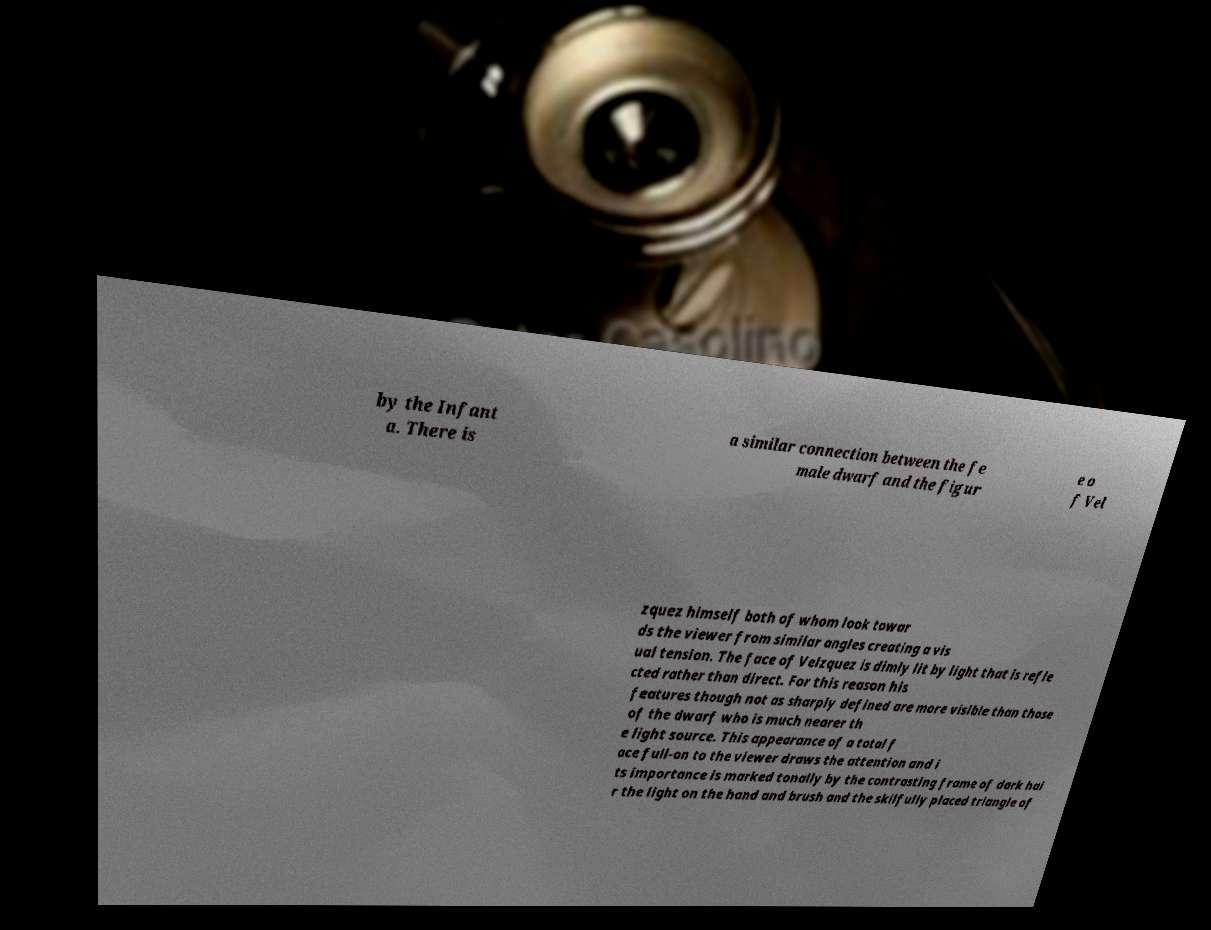What messages or text are displayed in this image? I need them in a readable, typed format. by the Infant a. There is a similar connection between the fe male dwarf and the figur e o f Vel zquez himself both of whom look towar ds the viewer from similar angles creating a vis ual tension. The face of Velzquez is dimly lit by light that is refle cted rather than direct. For this reason his features though not as sharply defined are more visible than those of the dwarf who is much nearer th e light source. This appearance of a total f ace full-on to the viewer draws the attention and i ts importance is marked tonally by the contrasting frame of dark hai r the light on the hand and brush and the skilfully placed triangle of 